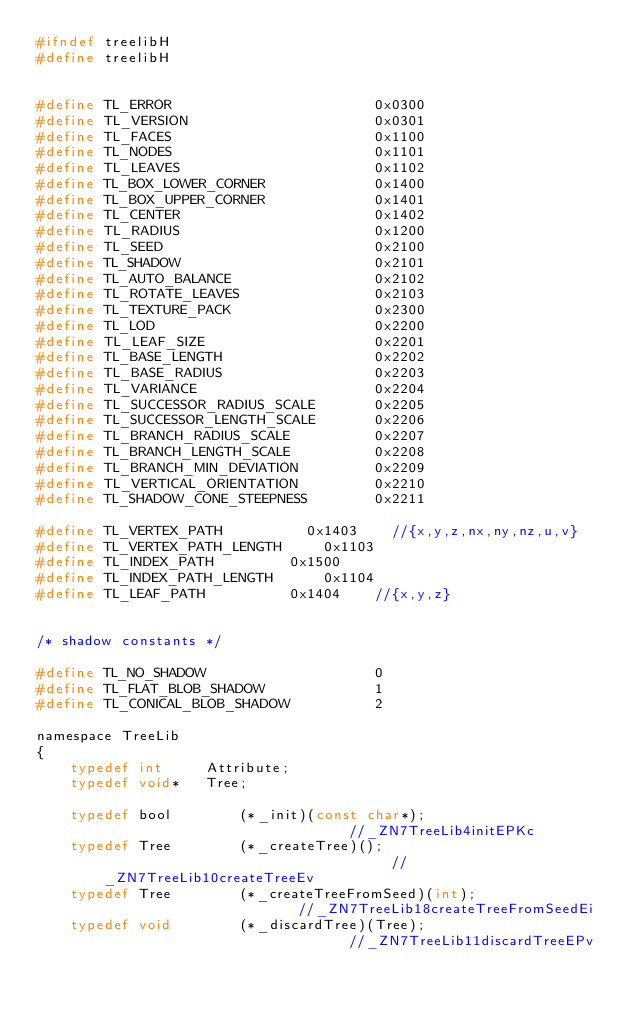<code> <loc_0><loc_0><loc_500><loc_500><_C_>#ifndef treelibH
#define treelibH


#define TL_ERROR                        0x0300
#define TL_VERSION                      0x0301
#define TL_FACES                        0x1100
#define TL_NODES                        0x1101
#define TL_LEAVES                       0x1102
#define TL_BOX_LOWER_CORNER             0x1400
#define TL_BOX_UPPER_CORNER             0x1401
#define TL_CENTER                       0x1402
#define TL_RADIUS                       0x1200
#define TL_SEED                         0x2100
#define TL_SHADOW                       0x2101
#define TL_AUTO_BALANCE                 0x2102
#define TL_ROTATE_LEAVES                0x2103
#define TL_TEXTURE_PACK                 0x2300
#define TL_LOD                          0x2200
#define TL_LEAF_SIZE                    0x2201
#define TL_BASE_LENGTH                  0x2202
#define TL_BASE_RADIUS                  0x2203
#define TL_VARIANCE                     0x2204
#define TL_SUCCESSOR_RADIUS_SCALE       0x2205
#define TL_SUCCESSOR_LENGTH_SCALE       0x2206
#define TL_BRANCH_RADIUS_SCALE          0x2207
#define TL_BRANCH_LENGTH_SCALE          0x2208
#define TL_BRANCH_MIN_DEVIATION         0x2209
#define TL_VERTICAL_ORIENTATION         0x2210
#define TL_SHADOW_CONE_STEEPNESS        0x2211

#define TL_VERTEX_PATH					0x1403		//{x,y,z,nx,ny,nz,u,v}
#define	TL_VERTEX_PATH_LENGTH			0x1103
#define TL_INDEX_PATH					0x1500
#define TL_INDEX_PATH_LENGTH			0x1104
#define TL_LEAF_PATH					0x1404		//{x,y,z}


/* shadow constants */

#define TL_NO_SHADOW                    0
#define TL_FLAT_BLOB_SHADOW             1
#define TL_CONICAL_BLOB_SHADOW          2

namespace TreeLib
{
    typedef int     Attribute;
    typedef void*   Tree;

    typedef bool        (*_init)(const char*);                              //_ZN7TreeLib4initEPKc
    typedef Tree        (*_createTree)();                                   //_ZN7TreeLib10createTreeEv
    typedef Tree        (*_createTreeFromSeed)(int);                        //_ZN7TreeLib18createTreeFromSeedEi
    typedef void        (*_discardTree)(Tree);                              //_ZN7TreeLib11discardTreeEPv</code> 